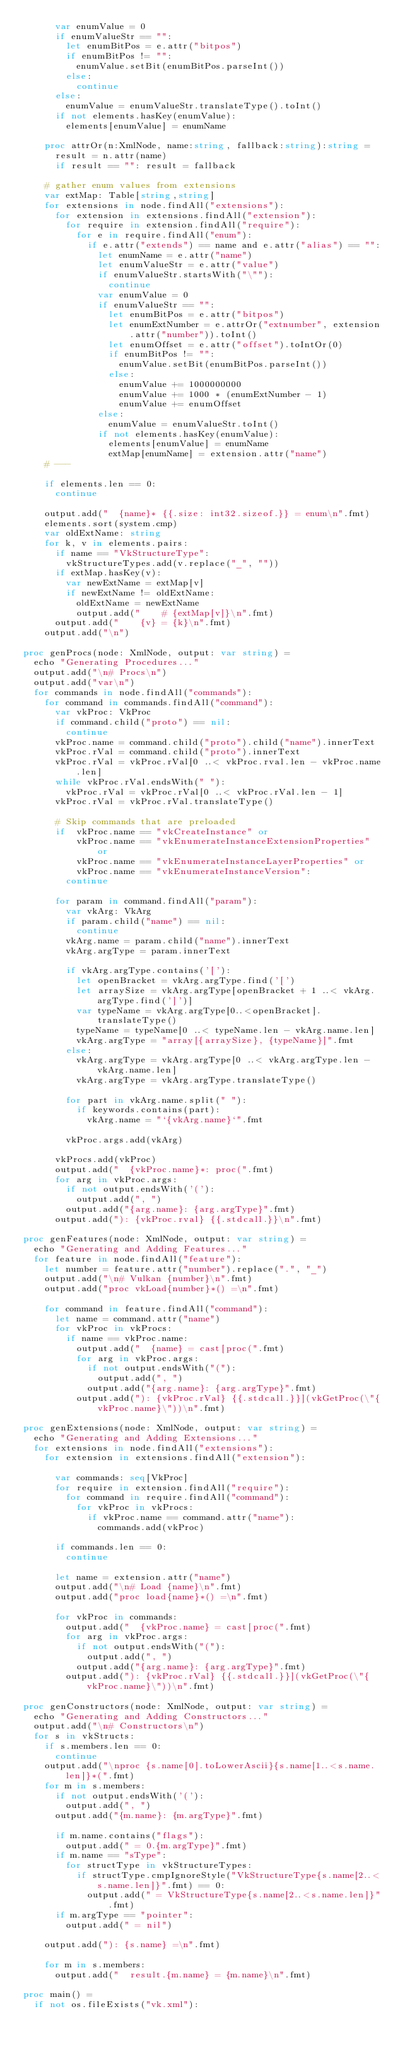Convert code to text. <code><loc_0><loc_0><loc_500><loc_500><_Nim_>      var enumValue = 0
      if enumValueStr == "":
        let enumBitPos = e.attr("bitpos")
        if enumBitPos != "":
          enumValue.setBit(enumBitPos.parseInt())
        else:
          continue
      else:
        enumValue = enumValueStr.translateType().toInt()
      if not elements.hasKey(enumValue):
        elements[enumValue] = enumName

    proc attrOr(n:XmlNode, name:string, fallback:string):string =
      result = n.attr(name)
      if result == "": result = fallback

    # gather enum values from extensions
    var extMap: Table[string,string]
    for extensions in node.findAll("extensions"):
      for extension in extensions.findAll("extension"):
        for require in extension.findAll("require"):
          for e in require.findAll("enum"):
            if e.attr("extends") == name and e.attr("alias") == "":
              let enumName = e.attr("name")
              let enumValueStr = e.attr("value")
              if enumValueStr.startsWith("\""):
                continue
              var enumValue = 0
              if enumValueStr == "":
                let enumBitPos = e.attr("bitpos")
                let enumExtNumber = e.attrOr("extnumber", extension.attr("number")).toInt()
                let enumOffset = e.attr("offset").toIntOr(0)
                if enumBitPos != "":
                  enumValue.setBit(enumBitPos.parseInt())
                else:
                  enumValue += 1000000000
                  enumValue += 1000 * (enumExtNumber - 1)
                  enumValue += enumOffset
              else:
                enumValue = enumValueStr.toInt()
              if not elements.hasKey(enumValue):
                elements[enumValue] = enumName
                extMap[enumName] = extension.attr("name")
    # ---

    if elements.len == 0:
      continue

    output.add("  {name}* {{.size: int32.sizeof.}} = enum\n".fmt)
    elements.sort(system.cmp)
    var oldExtName: string
    for k, v in elements.pairs:
      if name == "VkStructureType":
        vkStructureTypes.add(v.replace("_", ""))
      if extMap.hasKey(v):
        var newExtName = extMap[v]
        if newExtName != oldExtName:
          oldExtName = newExtName
          output.add("    # {extMap[v]}\n".fmt)
      output.add("    {v} = {k}\n".fmt)
    output.add("\n")

proc genProcs(node: XmlNode, output: var string) =
  echo "Generating Procedures..."
  output.add("\n# Procs\n")
  output.add("var\n")
  for commands in node.findAll("commands"):
    for command in commands.findAll("command"):
      var vkProc: VkProc
      if command.child("proto") == nil:
        continue
      vkProc.name = command.child("proto").child("name").innerText
      vkProc.rVal = command.child("proto").innerText
      vkProc.rVal = vkProc.rVal[0 ..< vkProc.rval.len - vkProc.name.len]
      while vkProc.rVal.endsWith(" "):
        vkProc.rVal = vkProc.rVal[0 ..< vkProc.rVal.len - 1]
      vkProc.rVal = vkProc.rVal.translateType()

      # Skip commands that are preloaded
      if  vkProc.name == "vkCreateInstance" or
          vkProc.name == "vkEnumerateInstanceExtensionProperties" or
          vkProc.name == "vkEnumerateInstanceLayerProperties" or
          vkProc.name == "vkEnumerateInstanceVersion":
        continue

      for param in command.findAll("param"):
        var vkArg: VkArg
        if param.child("name") == nil:
          continue
        vkArg.name = param.child("name").innerText
        vkArg.argType = param.innerText

        if vkArg.argType.contains('['):
          let openBracket = vkArg.argType.find('[')
          let arraySize = vkArg.argType[openBracket + 1 ..< vkArg.argType.find(']')]
          var typeName = vkArg.argType[0..<openBracket].translateType()
          typeName = typeName[0 ..< typeName.len - vkArg.name.len]
          vkArg.argType = "array[{arraySize}, {typeName}]".fmt
        else:
          vkArg.argType = vkArg.argType[0 ..< vkArg.argType.len - vkArg.name.len]
          vkArg.argType = vkArg.argType.translateType()

        for part in vkArg.name.split(" "):
          if keywords.contains(part):
            vkArg.name = "`{vkArg.name}`".fmt

        vkProc.args.add(vkArg)

      vkProcs.add(vkProc)
      output.add("  {vkProc.name}*: proc(".fmt)
      for arg in vkProc.args:
        if not output.endsWith('('):
          output.add(", ")
        output.add("{arg.name}: {arg.argType}".fmt)
      output.add("): {vkProc.rval} {{.stdcall.}}\n".fmt)

proc genFeatures(node: XmlNode, output: var string) =
  echo "Generating and Adding Features..."
  for feature in node.findAll("feature"):
    let number = feature.attr("number").replace(".", "_")
    output.add("\n# Vulkan {number}\n".fmt)
    output.add("proc vkLoad{number}*() =\n".fmt)

    for command in feature.findAll("command"):
      let name = command.attr("name")
      for vkProc in vkProcs:
        if name == vkProc.name:
          output.add("  {name} = cast[proc(".fmt)
          for arg in vkProc.args:
            if not output.endsWith("("):
              output.add(", ")
            output.add("{arg.name}: {arg.argType}".fmt)
          output.add("): {vkProc.rVal} {{.stdcall.}}](vkGetProc(\"{vkProc.name}\"))\n".fmt)

proc genExtensions(node: XmlNode, output: var string) =
  echo "Generating and Adding Extensions..."
  for extensions in node.findAll("extensions"):
    for extension in extensions.findAll("extension"):

      var commands: seq[VkProc]
      for require in extension.findAll("require"):
        for command in require.findAll("command"):
          for vkProc in vkProcs:
            if vkProc.name == command.attr("name"):
              commands.add(vkProc)

      if commands.len == 0:
        continue

      let name = extension.attr("name")
      output.add("\n# Load {name}\n".fmt)
      output.add("proc load{name}*() =\n".fmt)

      for vkProc in commands:
        output.add("  {vkProc.name} = cast[proc(".fmt)
        for arg in vkProc.args:
          if not output.endsWith("("):
            output.add(", ")
          output.add("{arg.name}: {arg.argType}".fmt)
        output.add("): {vkProc.rVal} {{.stdcall.}}](vkGetProc(\"{vkProc.name}\"))\n".fmt)

proc genConstructors(node: XmlNode, output: var string) =
  echo "Generating and Adding Constructors..."
  output.add("\n# Constructors\n")
  for s in vkStructs:
    if s.members.len == 0:
      continue
    output.add("\nproc {s.name[0].toLowerAscii}{s.name[1..<s.name.len]}*(".fmt)
    for m in s.members:
      if not output.endsWith('('):
        output.add(", ")
      output.add("{m.name}: {m.argType}".fmt)

      if m.name.contains("flags"):
        output.add(" = 0.{m.argType}".fmt)
      if m.name == "sType":
        for structType in vkStructureTypes:
          if structType.cmpIgnoreStyle("VkStructureType{s.name[2..<s.name.len]}".fmt) == 0:
            output.add(" = VkStructureType{s.name[2..<s.name.len]}".fmt)
      if m.argType == "pointer":
        output.add(" = nil")

    output.add("): {s.name} =\n".fmt)

    for m in s.members:
      output.add("  result.{m.name} = {m.name}\n".fmt)

proc main() =
  if not os.fileExists("vk.xml"):</code> 